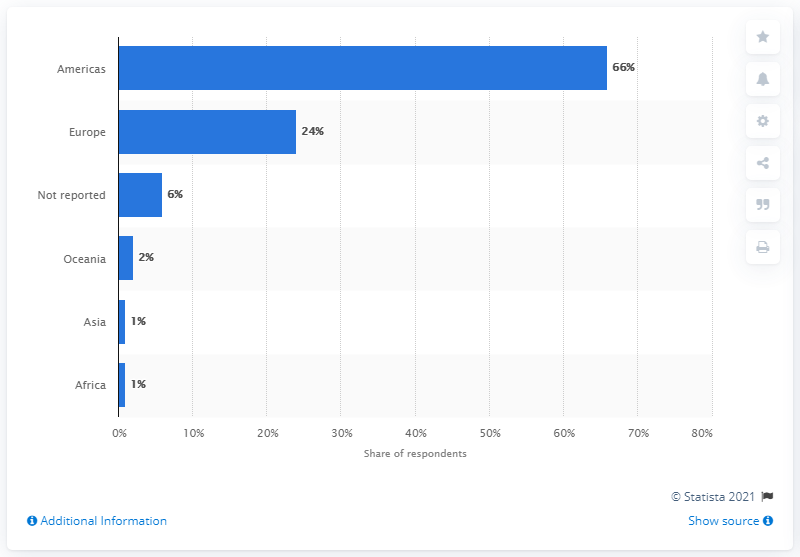Draw attention to some important aspects in this diagram. According to a survey of contact center industry leaders, 24% stated that their organization was located in Europe. 